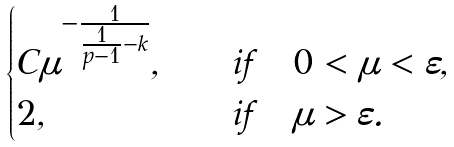Convert formula to latex. <formula><loc_0><loc_0><loc_500><loc_500>\begin{cases} C \mu ^ { - \frac { 1 } { \frac { 1 } { p - 1 } - k } } , & \quad i f \quad 0 < \mu < \varepsilon , \\ 2 , & \quad i f \quad \mu > \varepsilon . \end{cases}</formula> 